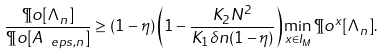Convert formula to latex. <formula><loc_0><loc_0><loc_500><loc_500>\frac { \P o [ \Lambda _ { n } ] } { \P o [ A _ { \ e p s , n } ] } \geq ( 1 - \eta ) \left ( 1 - \frac { K _ { 2 } N ^ { 2 } } { K _ { 1 } \delta n ( 1 - \eta ) } \right ) \min _ { x \in I _ { M } } \P o ^ { x } [ \Lambda _ { n } ] .</formula> 